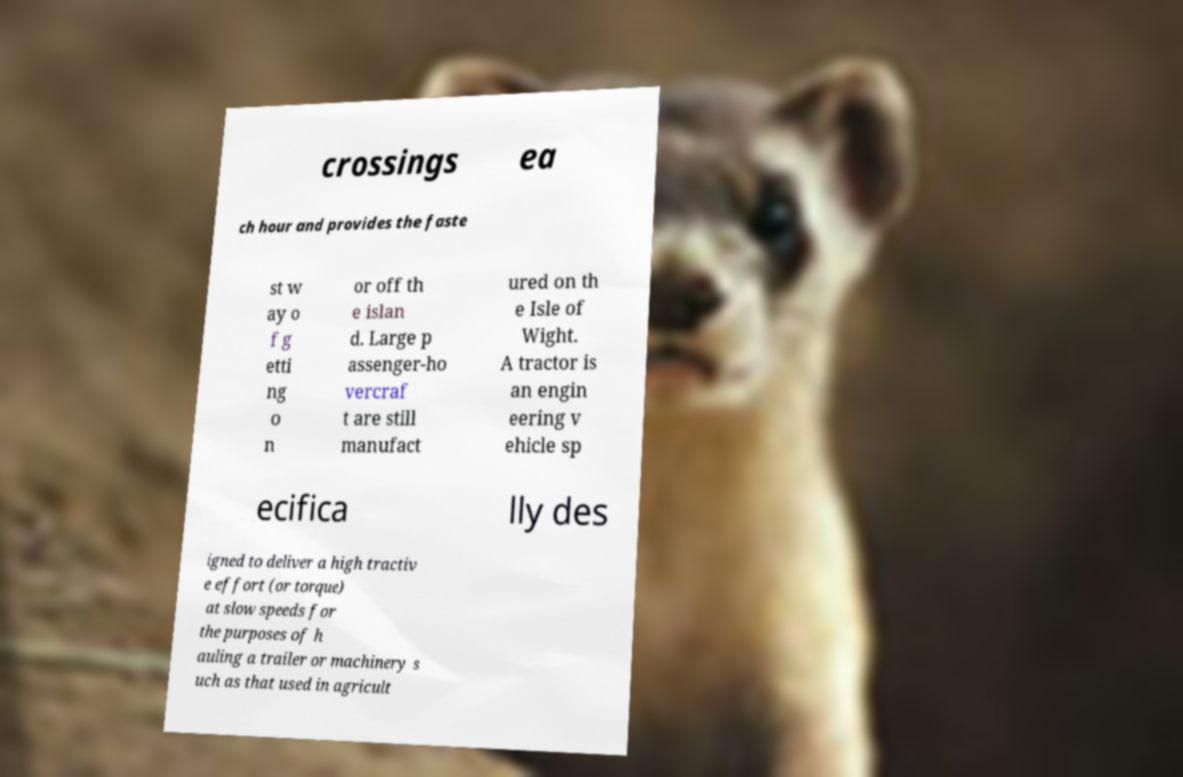Could you extract and type out the text from this image? crossings ea ch hour and provides the faste st w ay o f g etti ng o n or off th e islan d. Large p assenger-ho vercraf t are still manufact ured on th e Isle of Wight. A tractor is an engin eering v ehicle sp ecifica lly des igned to deliver a high tractiv e effort (or torque) at slow speeds for the purposes of h auling a trailer or machinery s uch as that used in agricult 